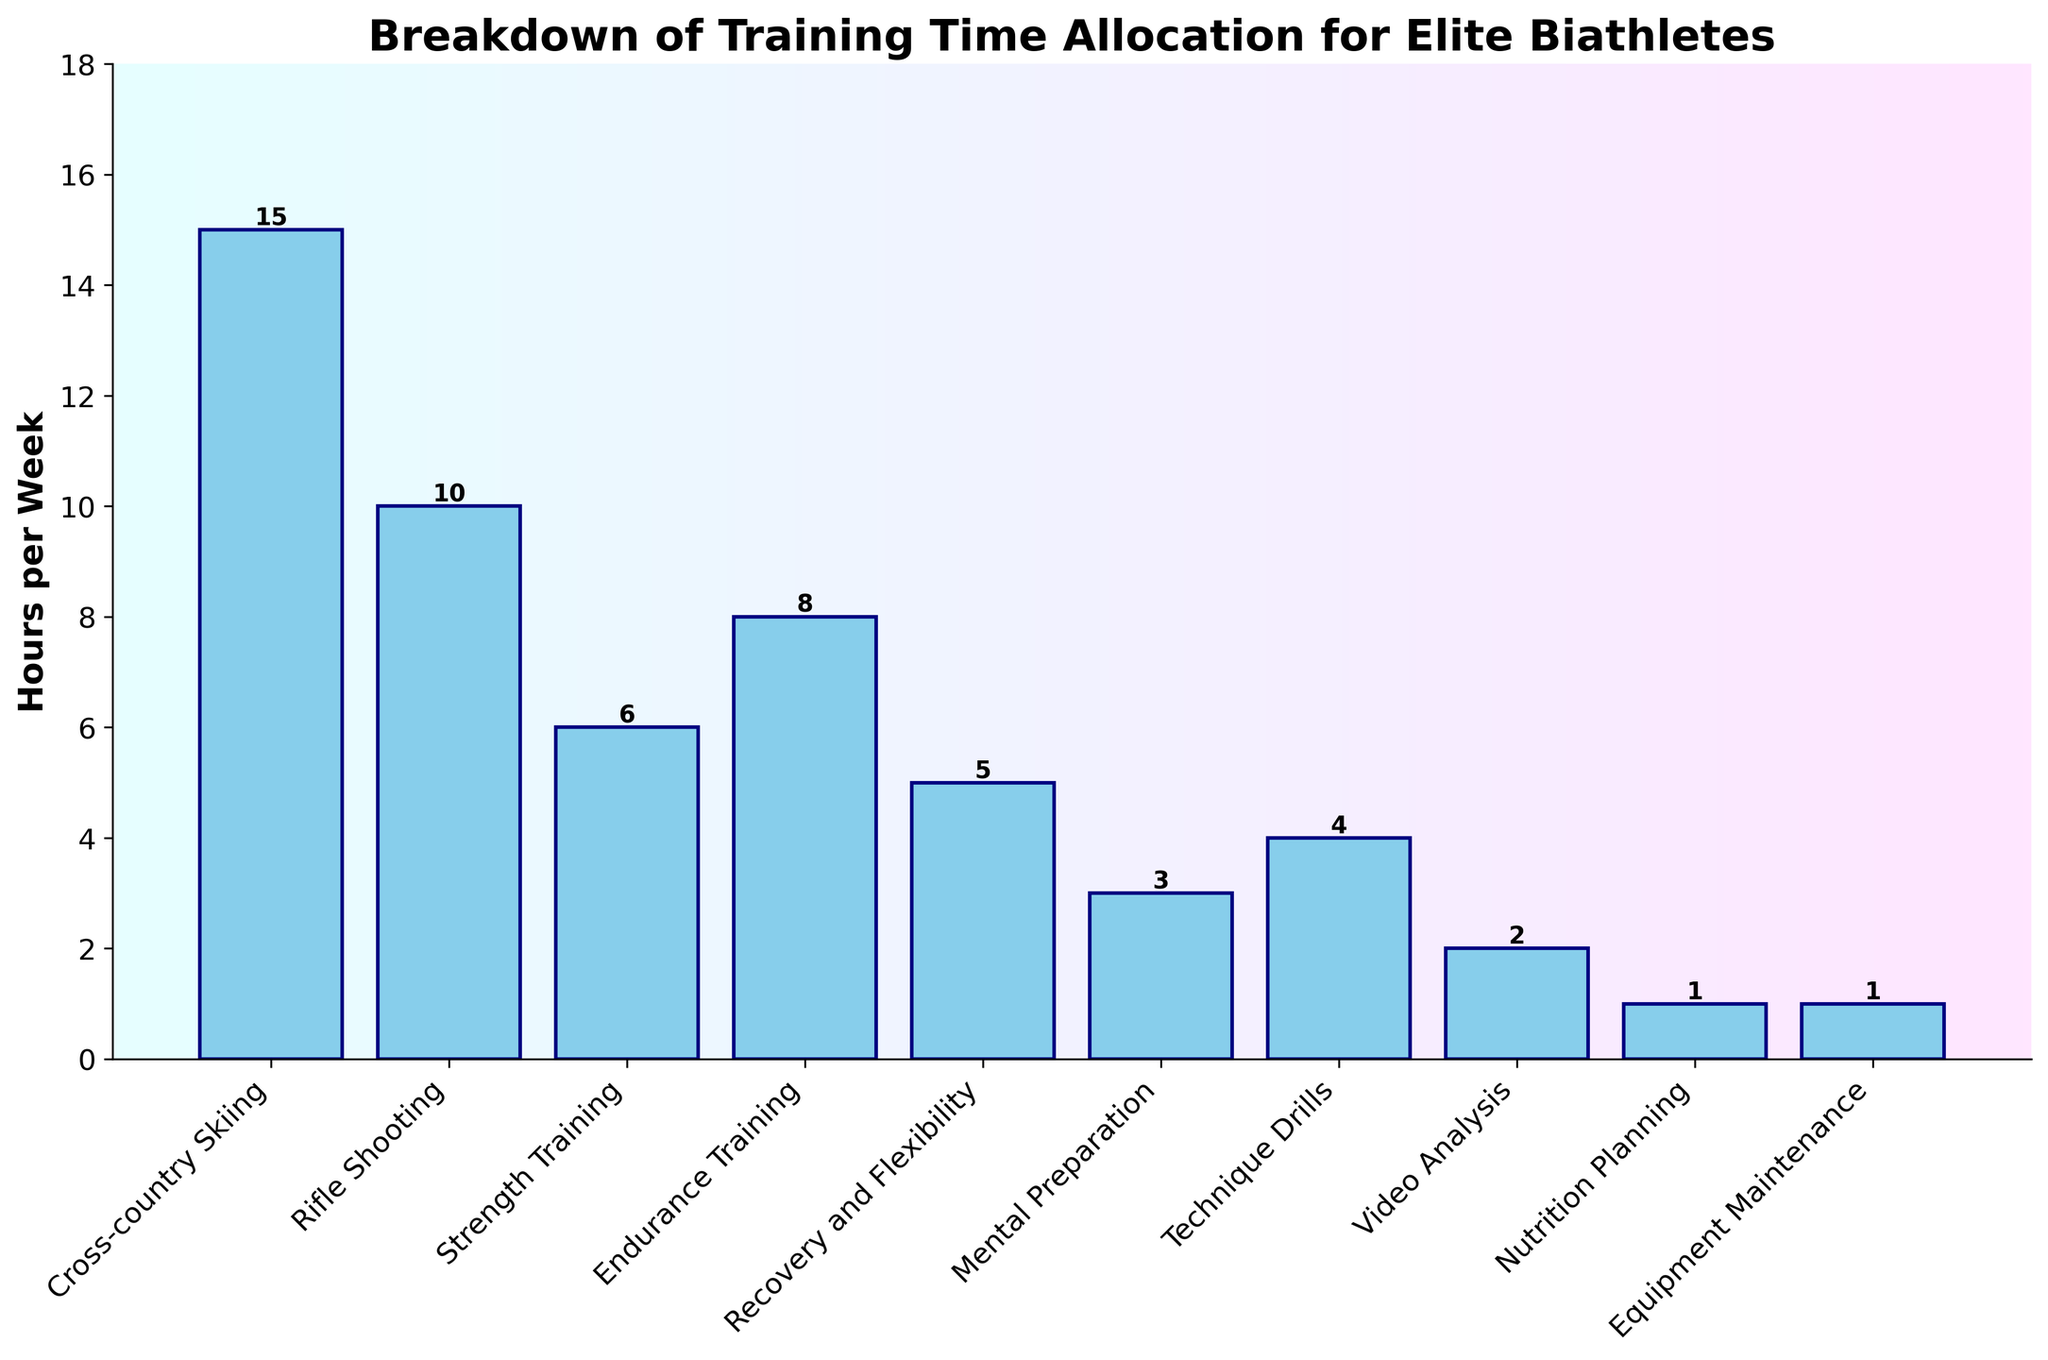Which activity takes up the most training time per week? The tallest bar in the chart indicates the activity with the highest number of training hours. Cross-country Skiing has the tallest bar.
Answer: Cross-country Skiing Which two activities combined sum up to more than 20 hours per week? By examining the bars, Cross-country Skiing (15 hours) and Rifle Shooting (10 hours) together total 25 hours.
Answer: Cross-country Skiing and Rifle Shooting How much more time is spent on Cross-country Skiing compared to Strength Training? Subtract the hours for Strength Training (6 hours) from the hours for Cross-country Skiing (15 hours). 15 - 6 = 9 hours.
Answer: 9 hours Which activities take up less than 5 hours per week? The bars shorter than 5 hours are Video Analysis, Nutrition Planning, Equipment Maintenance, Mental Preparation, and Technique Drills.
Answer: Video Analysis, Nutrition Planning, Equipment Maintenance, Mental Preparation, Technique Drills What is the average training time for the five activities with the least hours? Sum the hours for Video Analysis (2), Nutrition Planning (1), Equipment Maintenance (1), Mental Preparation (3), and Technique Drills (4), and then divide by 5. (2 + 1 + 1 + 3 + 4) / 5 = 11 / 5 = 2.2 hours.
Answer: 2.2 hours Which activity's training time is closest to the median value of all activities? Listing the hours: 1, 1, 2, 3, 4, 5, 6, 8, 10, 15. The median is the middle value for an even number of observations. The median is (4 + 5) / 2 = 4.5 hours. The closest to this is Recovery and Flexibility at 5 hours.
Answer: Recovery and Flexibility Which activities have a training time that is exactly equal to the average training time per activity? Calculate the total hours (55) and divide by 10 activities. The average time is 55 / 10 = 5.5 hours. None of the activities have exactly 5.5 hours.
Answer: None Is more time spent on Rifle Shooting or Endurance Training? The bar for Rifle Shooting (10 hours) is taller than that for Endurance Training (8 hours).
Answer: Rifle Shooting What is the total amount of time spent on Equipment Maintenance and Nutrition Planning? Add the hours for Equipment Maintenance (1 hour) and Nutrition Planning (1 hour). 1 + 1 = 2 hours.
Answer: 2 hours How does the total training time in mental and physical preparation activities compare? Sum the hours for Mental Preparation (3) and Rifle Shooting (10) for mental training (total = 13 hours). Sum the physical training hours: Cross-country Skiing (15), Strength Training (6), and Endurance Training (8) for a total of 29 hours. 29 is greater than 13.
Answer: Physical training is greater 